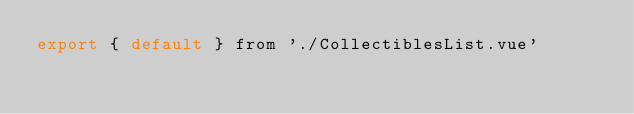<code> <loc_0><loc_0><loc_500><loc_500><_JavaScript_>export { default } from './CollectiblesList.vue'
</code> 